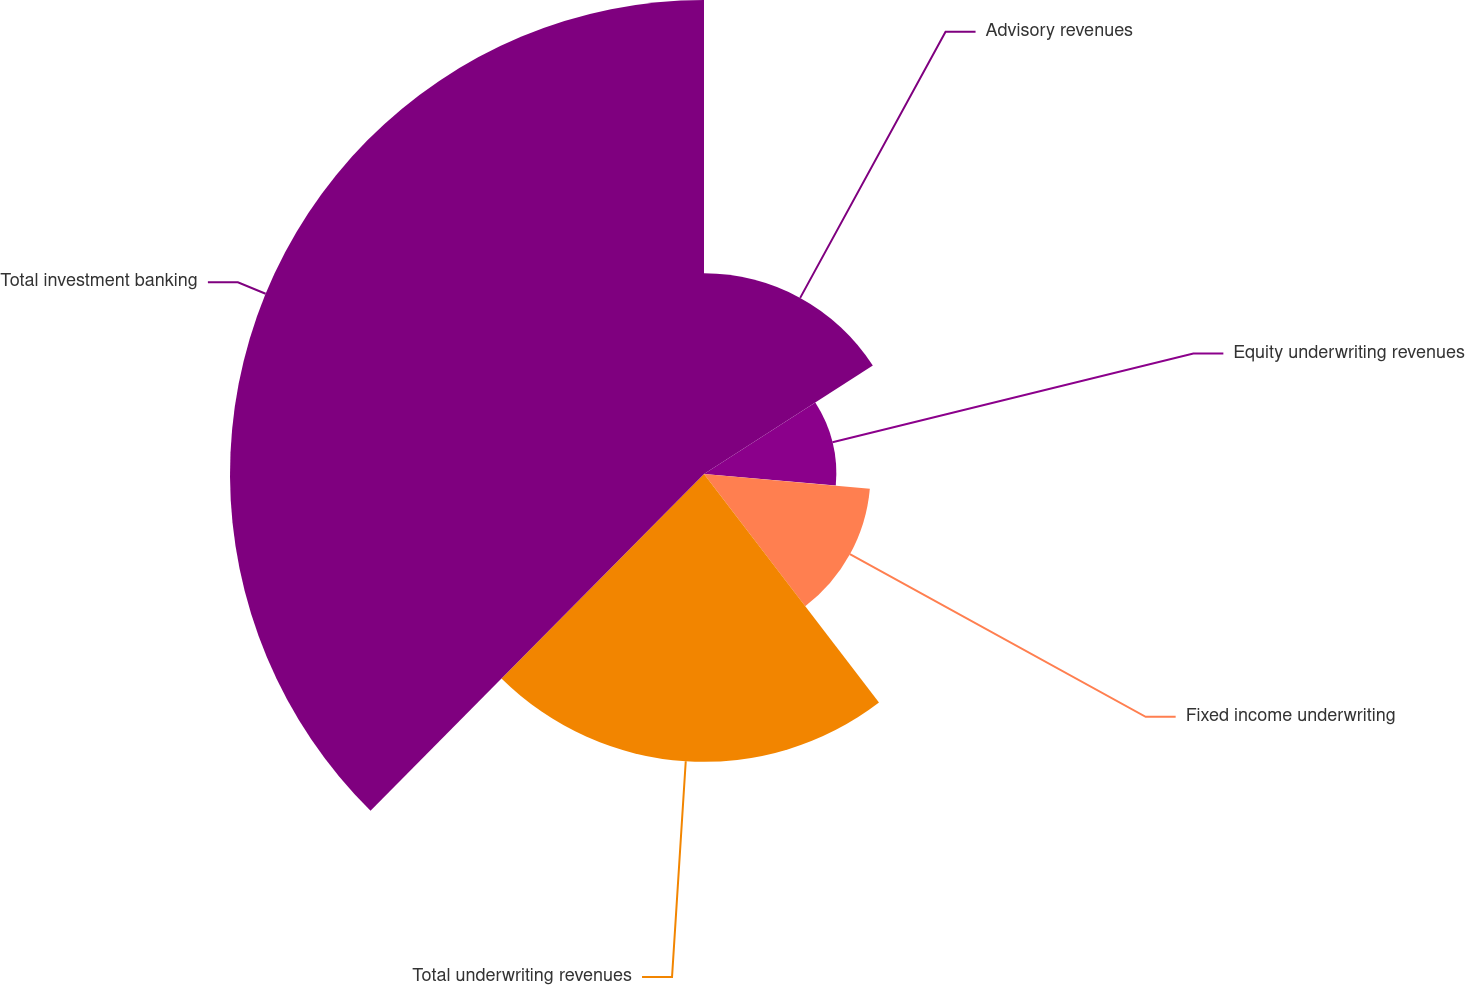Convert chart to OTSL. <chart><loc_0><loc_0><loc_500><loc_500><pie_chart><fcel>Advisory revenues<fcel>Equity underwriting revenues<fcel>Fixed income underwriting<fcel>Total underwriting revenues<fcel>Total investment banking<nl><fcel>15.91%<fcel>10.49%<fcel>13.2%<fcel>22.82%<fcel>37.58%<nl></chart> 